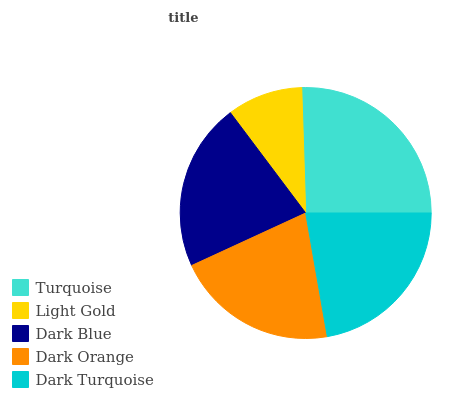Is Light Gold the minimum?
Answer yes or no. Yes. Is Turquoise the maximum?
Answer yes or no. Yes. Is Dark Blue the minimum?
Answer yes or no. No. Is Dark Blue the maximum?
Answer yes or no. No. Is Dark Blue greater than Light Gold?
Answer yes or no. Yes. Is Light Gold less than Dark Blue?
Answer yes or no. Yes. Is Light Gold greater than Dark Blue?
Answer yes or no. No. Is Dark Blue less than Light Gold?
Answer yes or no. No. Is Dark Blue the high median?
Answer yes or no. Yes. Is Dark Blue the low median?
Answer yes or no. Yes. Is Turquoise the high median?
Answer yes or no. No. Is Dark Turquoise the low median?
Answer yes or no. No. 